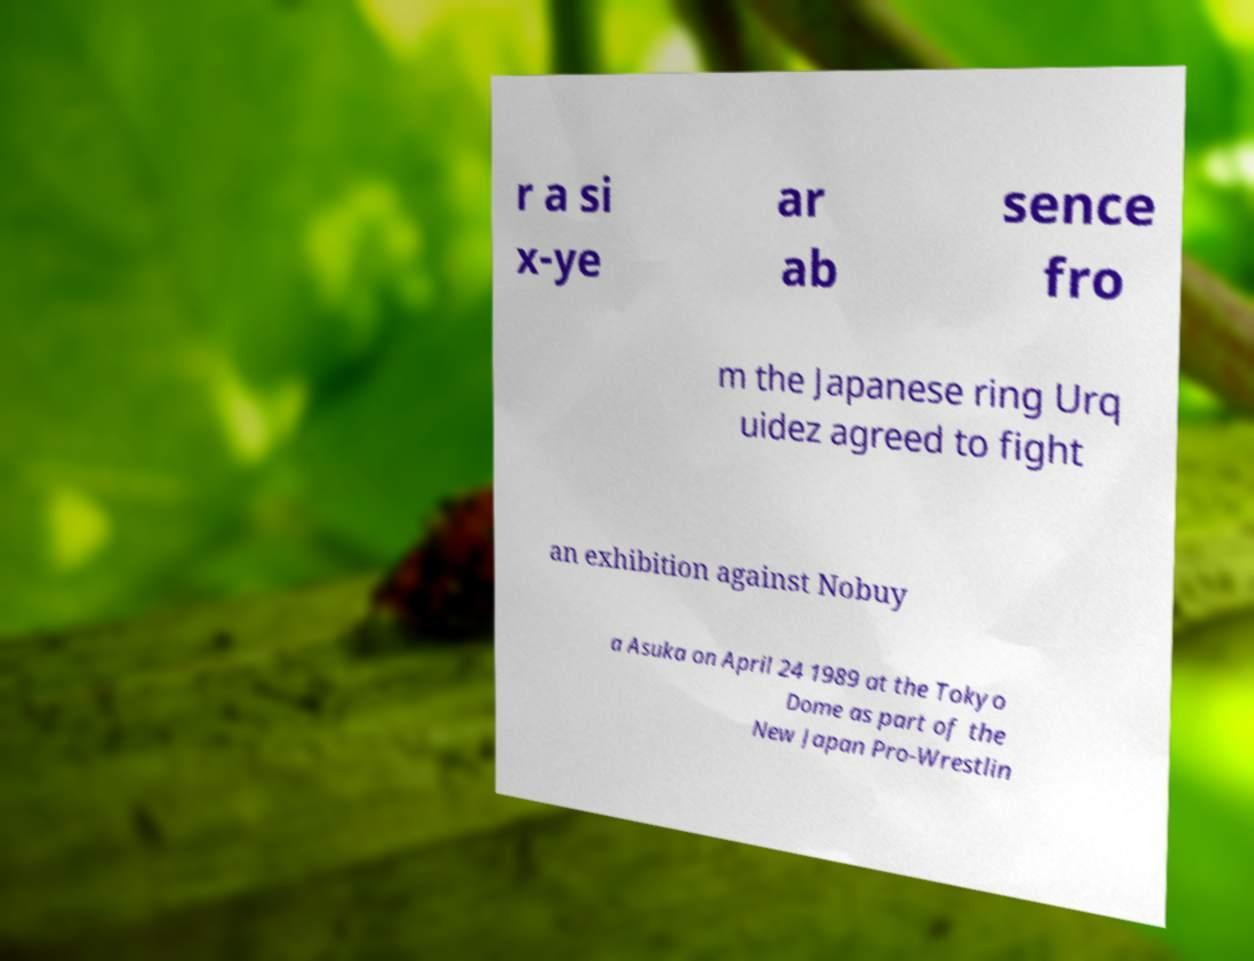Please identify and transcribe the text found in this image. r a si x-ye ar ab sence fro m the Japanese ring Urq uidez agreed to fight an exhibition against Nobuy a Asuka on April 24 1989 at the Tokyo Dome as part of the New Japan Pro-Wrestlin 